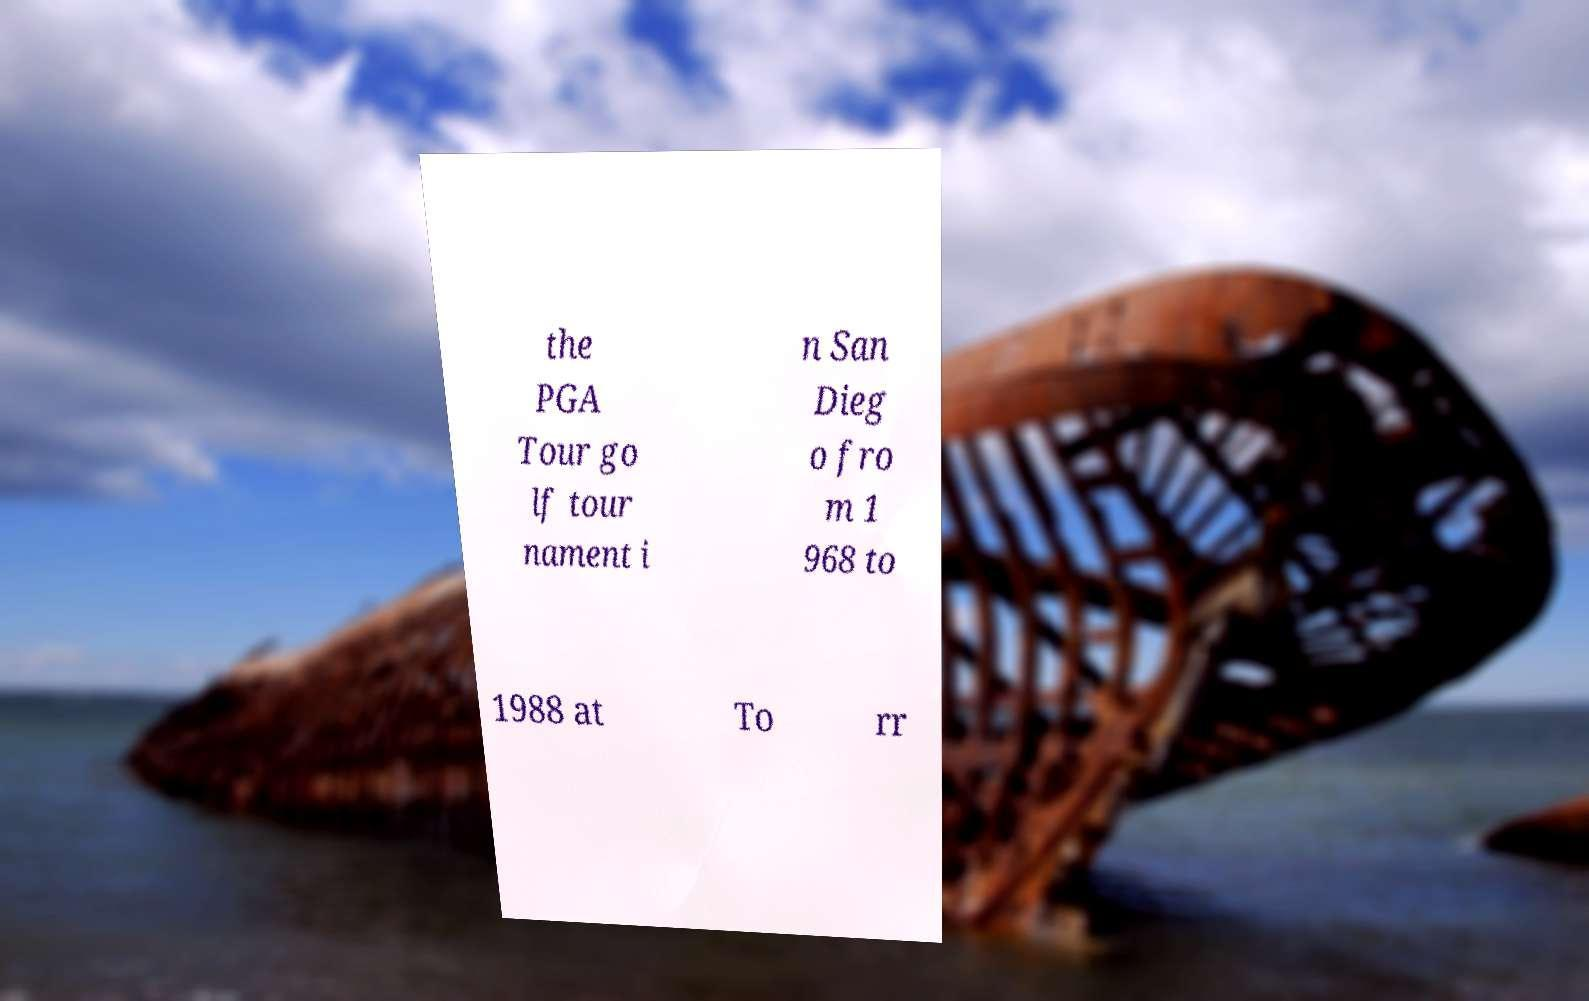Can you accurately transcribe the text from the provided image for me? the PGA Tour go lf tour nament i n San Dieg o fro m 1 968 to 1988 at To rr 